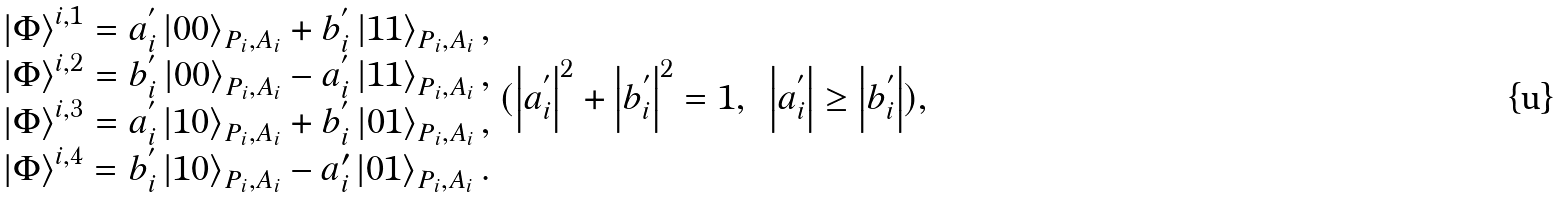<formula> <loc_0><loc_0><loc_500><loc_500>\begin{array} { c } \left | \Phi \right \rangle ^ { i , 1 } = a _ { i } ^ { ^ { \prime } } \left | 0 0 \right \rangle _ { P _ { i } , A _ { i } } + b _ { i } ^ { ^ { \prime } } \left | 1 1 \right \rangle _ { P _ { i } , A _ { i } } , \\ \left | \Phi \right \rangle ^ { i , 2 } = b _ { i } ^ { ^ { \prime } } \left | 0 0 \right \rangle _ { P _ { i } , A _ { i } } - a _ { i } ^ { ^ { \prime } } \left | 1 1 \right \rangle _ { P _ { i } , A _ { i } } , \\ \left | \Phi \right \rangle ^ { i , 3 } = a _ { i } ^ { ^ { \prime } } \left | 1 0 \right \rangle _ { P _ { i } , A _ { i } } + b _ { i } ^ { ^ { \prime } } \left | 0 1 \right \rangle _ { P _ { i } , A _ { i } } , \\ \left | \Phi \right \rangle ^ { i , 4 } = b _ { i } ^ { ^ { \prime } } \left | 1 0 \right \rangle _ { P _ { i } , A _ { i } } - a _ { i } ^ { \prime } \left | 0 1 \right \rangle _ { P _ { i } , A _ { i } } . \end{array} ( \left | a _ { i } ^ { ^ { \prime } } \right | ^ { 2 } + \left | b _ { i } ^ { ^ { \prime } } \right | ^ { 2 } = 1 , \text { } \left | a _ { i } ^ { ^ { \prime } } \right | \geq \left | b _ { i } ^ { ^ { \prime } } \right | ) ,</formula> 